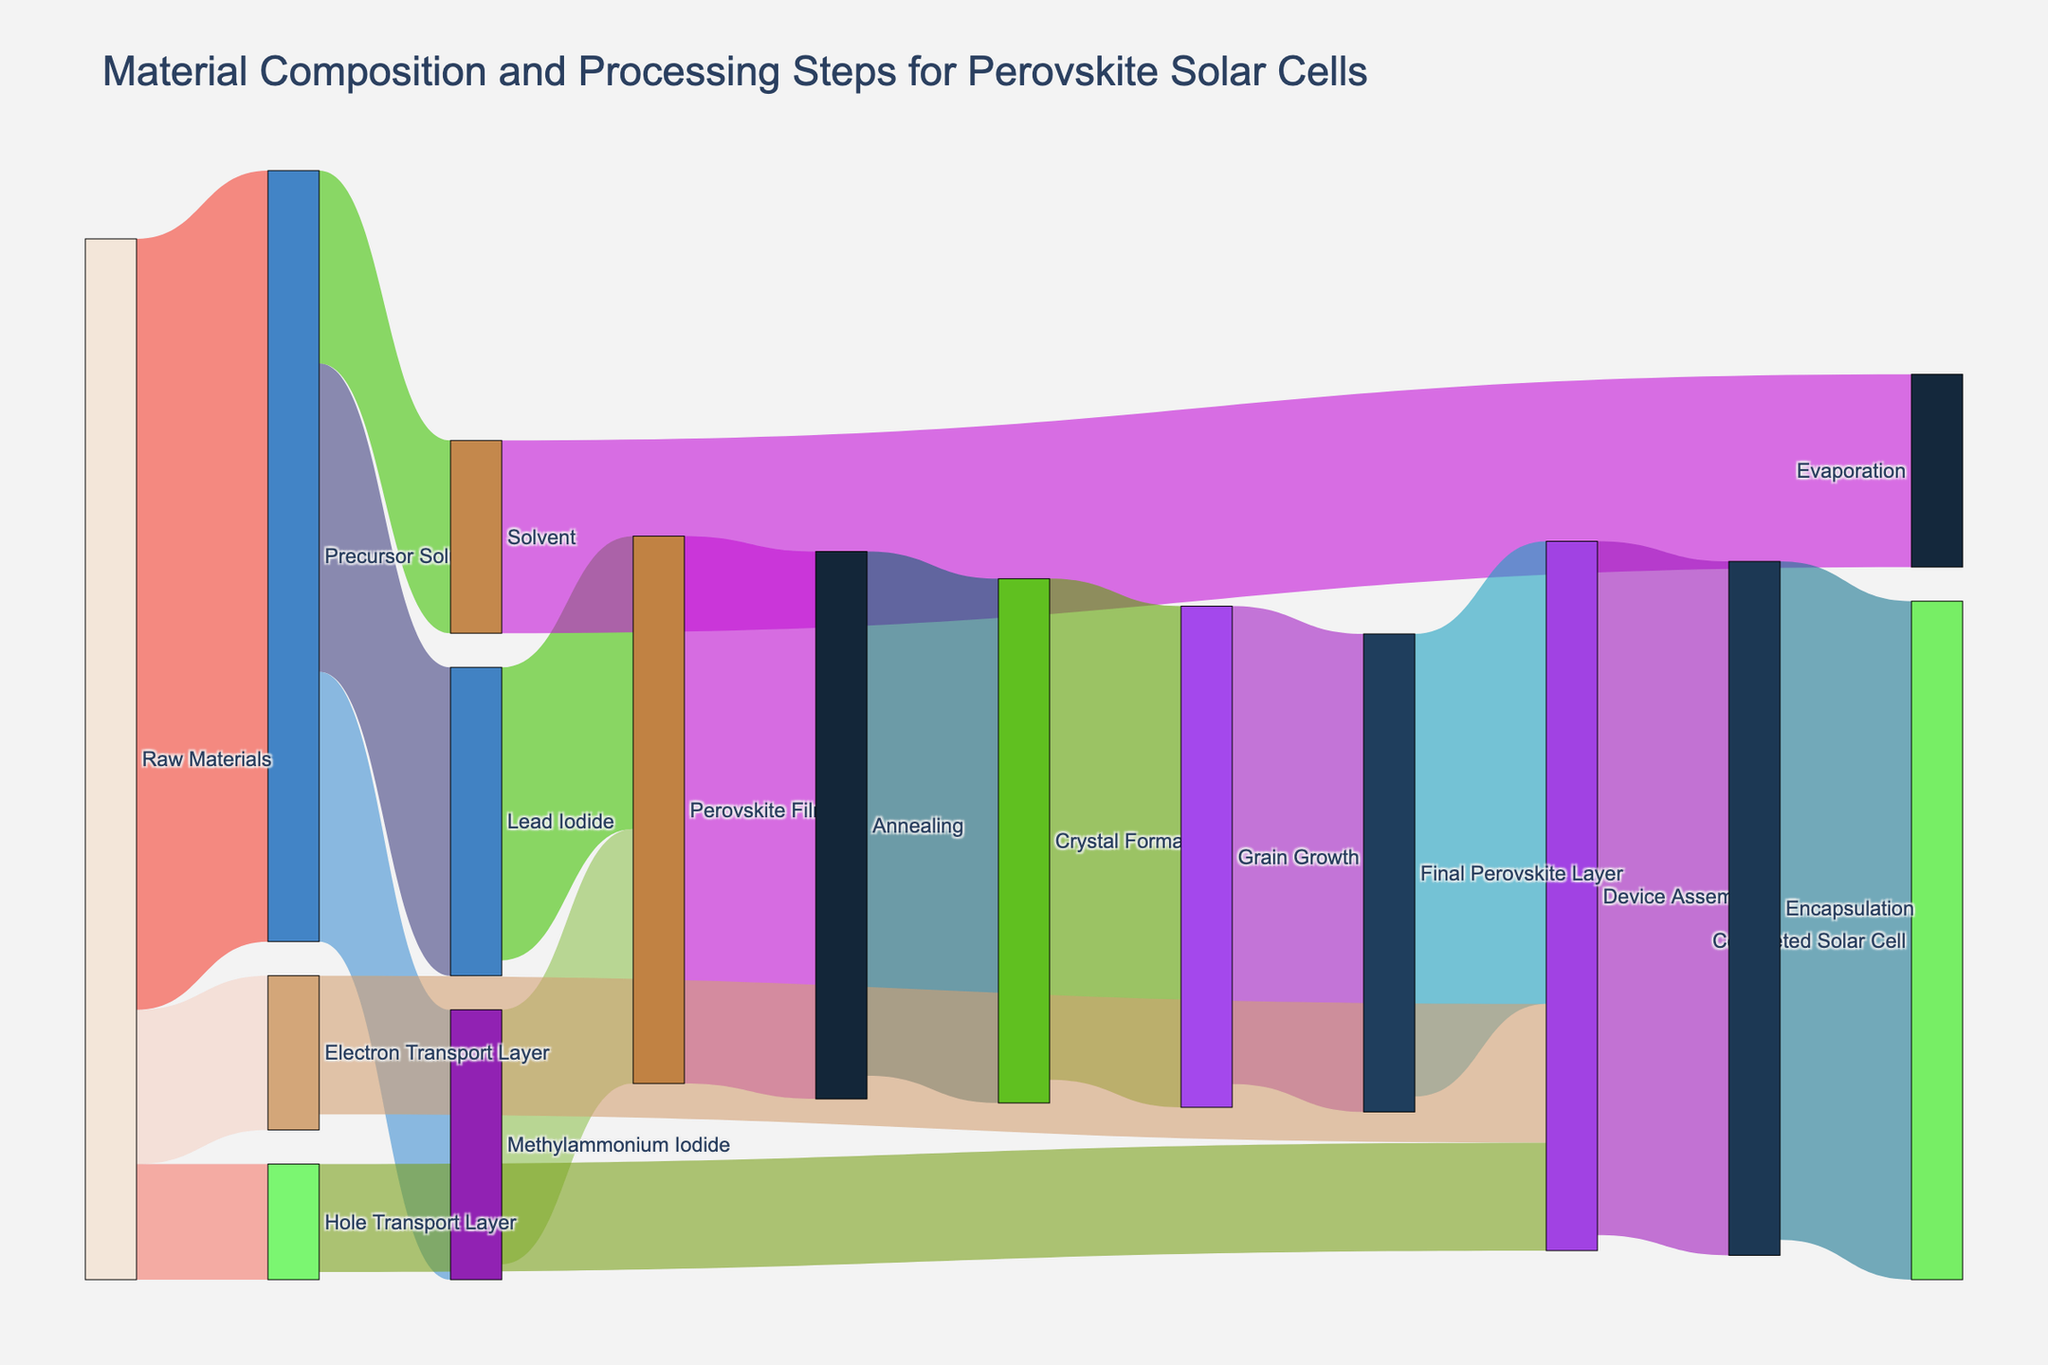What's the title of the Sankey diagram? The title is typically displayed at the top of the diagram, summarizing the purpose or content of the visualization. In this case, it reads "Material Composition and Processing Steps for Perovskite Solar Cells."
Answer: Material Composition and Processing Steps for Perovskite Solar Cells How many raw materials are involved in the initial stage? The initial stage, "Raw Materials," splits into several categories. By tracing from "Raw Materials," we see branches leading to "Precursor Solution," "Electron Transport Layer," and "Hole Transport Layer." Counting these, we get three.
Answer: 3 What is the value transferred from the "Precursor Solution" to "Lead Iodide"? The link between "Precursor Solution" and "Lead Iodide" is labeled with the value '40', representing the amount being transferred.
Answer: 40 Which material/input contributes the most to the "Precursor Solution"? By examining the values going into the "Precursor Solution," we see 100 coming from "Raw Materials," which is the highest contributing value.
Answer: Raw Materials How many processing steps lead to the "Completed Solar Cell"? To determine this, trace the path from "Raw Materials" to "Completed Solar Cell": Raw Materials → Device Assembly → Encapsulation → Completed Solar Cell. This results in three steps.
Answer: 3 What is the total value of the materials going into "Device Assembly"? Sum the values of the links going into "Device Assembly" which are from "Final Perovskite Layer" (60), "Electron Transport Layer" (18), and "Hole Transport Layer" (14): 60 + 18 + 14 = 92.
Answer: 92 How much of the "Precursor Solution" is not used in creating the "Perovskite Film"? Sum the values of "Lead Iodide" (40) and "Methylammonium Iodide" (35) being used to form the "Perovskite Film," and subtract from the total of "Precursor Solution" (100): 100 - (40 + 35) = 25.
Answer: 25 Which step has the highest value leading to "Device Assembly"? By comparing the values leading to "Device Assembly," the highest value comes from the "Final Perovskite Layer" which is 60.
Answer: Final Perovskite Layer How much material is lost between "Grain Growth" and "Final Perovskite Layer"? By calculating the difference between "Grain Growth" (65) and "Final Perovskite Layer" (62): 65 - 62 = 3.
Answer: 3 What stage follows directly after "Annealing"? By tracing the link that comes directly after "Annealing," we see it leads to "Crystal Formation."
Answer: Crystal Formation 